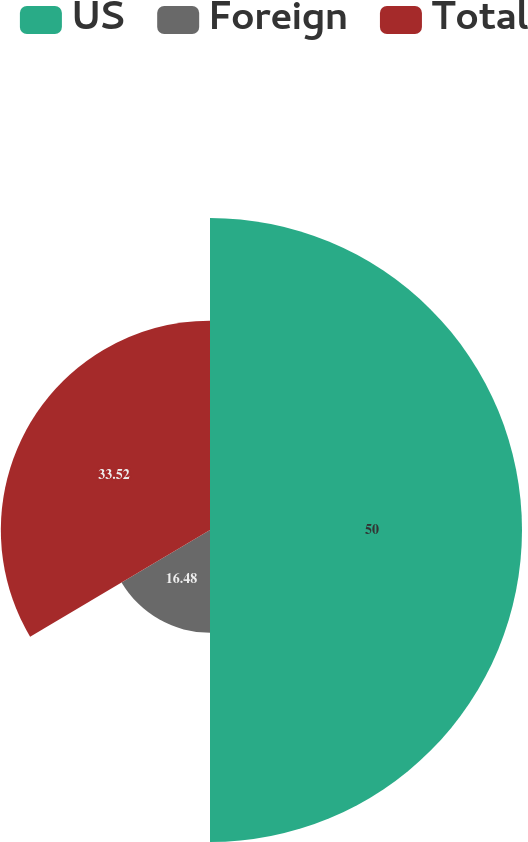Convert chart to OTSL. <chart><loc_0><loc_0><loc_500><loc_500><pie_chart><fcel>US<fcel>Foreign<fcel>Total<nl><fcel>50.0%<fcel>16.48%<fcel>33.52%<nl></chart> 